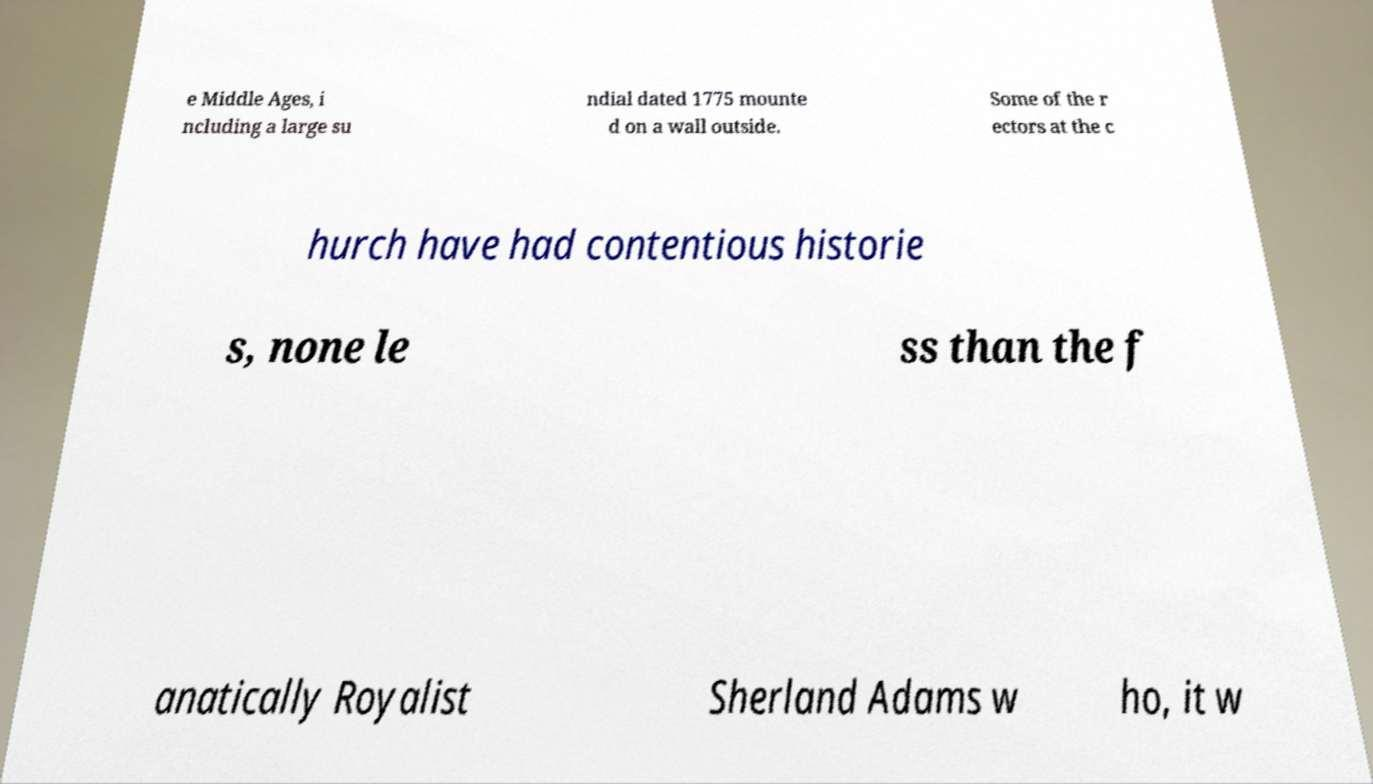Please identify and transcribe the text found in this image. e Middle Ages, i ncluding a large su ndial dated 1775 mounte d on a wall outside. Some of the r ectors at the c hurch have had contentious historie s, none le ss than the f anatically Royalist Sherland Adams w ho, it w 